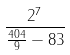<formula> <loc_0><loc_0><loc_500><loc_500>\frac { 2 ^ { 7 } } { \frac { 4 0 4 } { 9 } - 8 3 }</formula> 